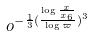<formula> <loc_0><loc_0><loc_500><loc_500>o ^ { - \frac { 1 } { 3 } ( \frac { \log \frac { x } { x _ { 6 } } } { \log \varpi } ) ^ { 3 } }</formula> 